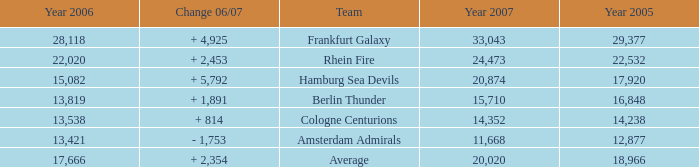What is the sum of Year 2007(s), when the Year 2005 is greater than 29,377? None. 